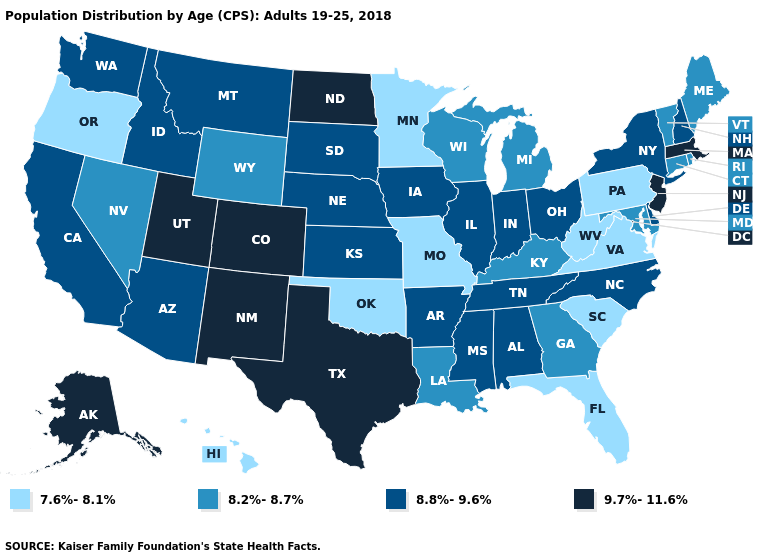Which states have the lowest value in the USA?
Write a very short answer. Florida, Hawaii, Minnesota, Missouri, Oklahoma, Oregon, Pennsylvania, South Carolina, Virginia, West Virginia. What is the value of Hawaii?
Answer briefly. 7.6%-8.1%. Name the states that have a value in the range 8.2%-8.7%?
Concise answer only. Connecticut, Georgia, Kentucky, Louisiana, Maine, Maryland, Michigan, Nevada, Rhode Island, Vermont, Wisconsin, Wyoming. Name the states that have a value in the range 9.7%-11.6%?
Keep it brief. Alaska, Colorado, Massachusetts, New Jersey, New Mexico, North Dakota, Texas, Utah. Is the legend a continuous bar?
Short answer required. No. What is the value of Louisiana?
Write a very short answer. 8.2%-8.7%. Name the states that have a value in the range 8.2%-8.7%?
Quick response, please. Connecticut, Georgia, Kentucky, Louisiana, Maine, Maryland, Michigan, Nevada, Rhode Island, Vermont, Wisconsin, Wyoming. Does the first symbol in the legend represent the smallest category?
Quick response, please. Yes. What is the highest value in states that border Iowa?
Answer briefly. 8.8%-9.6%. Among the states that border Delaware , does Pennsylvania have the lowest value?
Be succinct. Yes. Which states have the lowest value in the Northeast?
Quick response, please. Pennsylvania. Name the states that have a value in the range 7.6%-8.1%?
Short answer required. Florida, Hawaii, Minnesota, Missouri, Oklahoma, Oregon, Pennsylvania, South Carolina, Virginia, West Virginia. What is the value of Utah?
Short answer required. 9.7%-11.6%. What is the value of Arkansas?
Give a very brief answer. 8.8%-9.6%. Name the states that have a value in the range 7.6%-8.1%?
Give a very brief answer. Florida, Hawaii, Minnesota, Missouri, Oklahoma, Oregon, Pennsylvania, South Carolina, Virginia, West Virginia. 